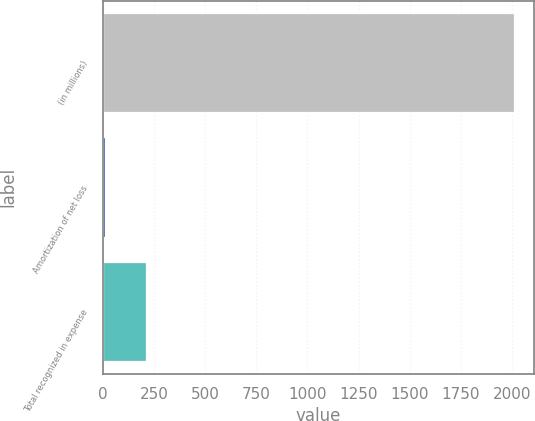<chart> <loc_0><loc_0><loc_500><loc_500><bar_chart><fcel>(in millions)<fcel>Amortization of net loss<fcel>Total recognized in expense<nl><fcel>2009<fcel>11<fcel>210.8<nl></chart> 